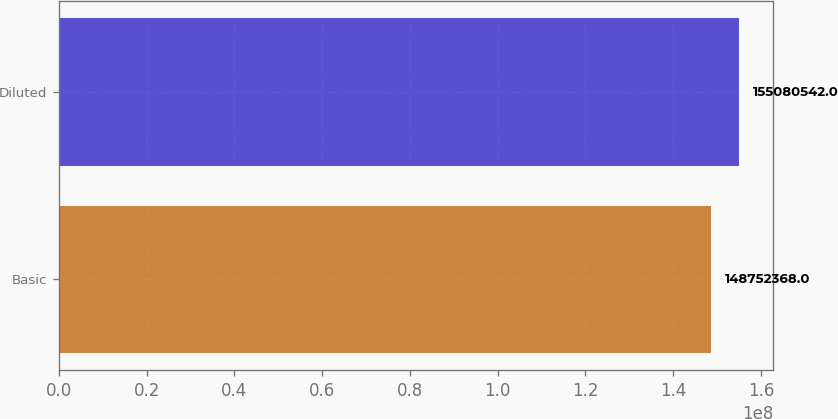Convert chart to OTSL. <chart><loc_0><loc_0><loc_500><loc_500><bar_chart><fcel>Basic<fcel>Diluted<nl><fcel>1.48752e+08<fcel>1.55081e+08<nl></chart> 